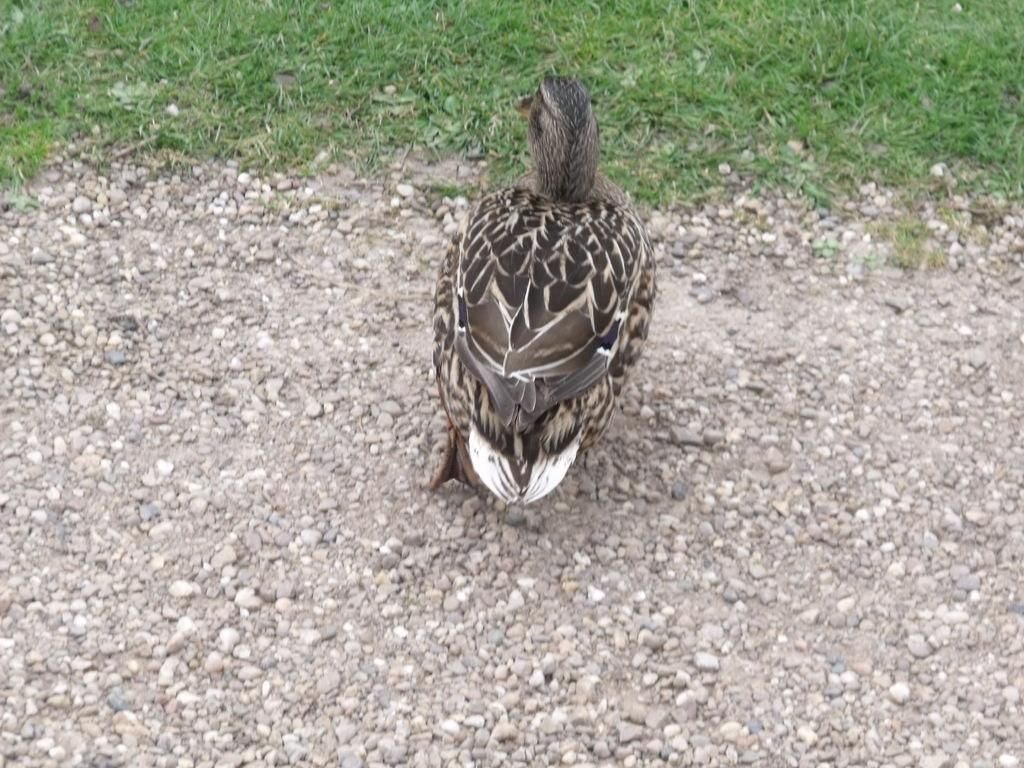What type of animal can be seen in the image? There is a bird in the image. Can you describe the bird's coloring? The bird is gray and white in color. What type of terrain is visible in the image? There is sand and grass in the image. What type of celery is the bird eating in the image? There is no celery present in the image; the bird is not shown eating anything. 